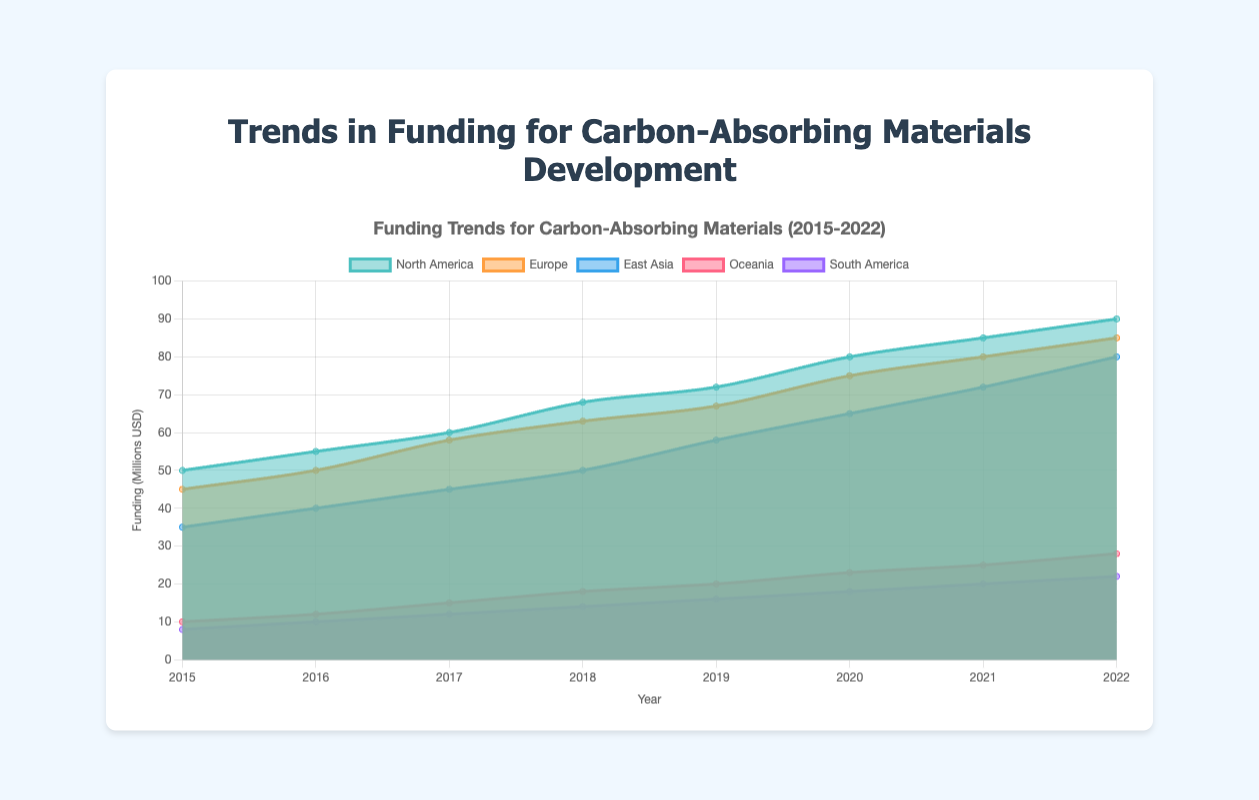What is the title of the chart? The title is displayed at the top of the chart and reads "Funding Trends for Carbon-Absorbing Materials (2015-2022)."
Answer: Funding Trends for Carbon-Absorbing Materials (2015-2022) What is the funding amount for North America in 2022? Locate North America's data line, identify the point for the year 2022, which indicates the funding value as $90 million.
Answer: 90 million USD How much did the funding for Europe increase from 2018 to 2020? Identify the funding for Europe in 2018 ($63 million) and 2020 ($75 million), then calculate the difference: $75m - $63m = $12 million.
Answer: 12 million USD Which region had the lowest funding in 2015 and what was the amount? Inspect the chart's data lines for 2015; South America had the lowest funding at $8 million.
Answer: South America, 8 million USD Compare the funding growth rates of Oceania and South America from 2015 to 2022. Which region had a higher growth rate? Oceania's funding grew from $10 million to $28 million, a $18 million increase, while South America’s grew from $8 million to $22 million, a $14 million increase. Oceania has a higher growth rate.
Answer: Oceania What was the total funding for East Asia across all years? Sum East Asia's funding values from 2015 to 2022: 35 + 40 + 45 + 50 + 58 + 65 + 72 + 80 = 445 million USD.
Answer: 445 million USD Which region showed a consistently increasing trend in funding over the period? Inspect each regions' data lines; all regions show an increasing trend, but the slope can be different.
Answer: All regions Between 2017 and 2018, which region experienced the highest increase in funding? Compare the differences between funding values from 2017 to 2018: North America ($8 million), Europe ($5 million), East Asia ($5 million), Oceania ($3 million), South America ($2 million). North America had the highest increase.
Answer: North America What is the average annual funding for Europe over the period? Calculate the average of Europe's annual funding values: (45 + 50 + 58 + 63 + 67 + 75 + 80 + 85) / 8 = 65.375 million USD.
Answer: 65.375 million USD 